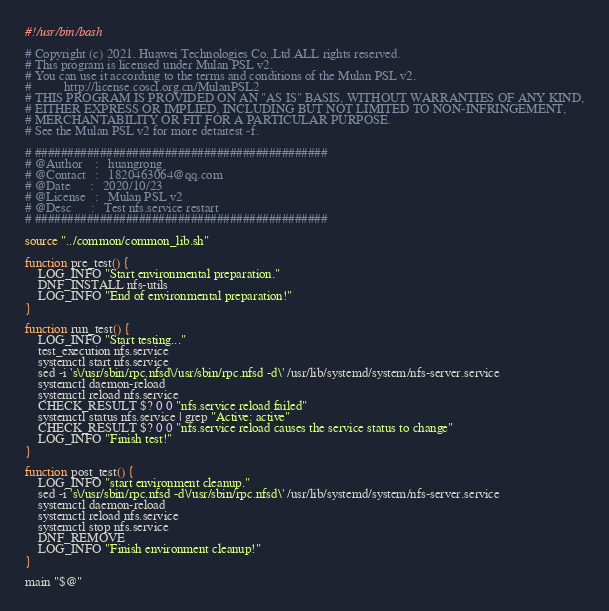Convert code to text. <code><loc_0><loc_0><loc_500><loc_500><_Bash_>#!/usr/bin/bash

# Copyright (c) 2021. Huawei Technologies Co.,Ltd.ALL rights reserved.
# This program is licensed under Mulan PSL v2.
# You can use it according to the terms and conditions of the Mulan PSL v2.
#          http://license.coscl.org.cn/MulanPSL2
# THIS PROGRAM IS PROVIDED ON AN "AS IS" BASIS, WITHOUT WARRANTIES OF ANY KIND,
# EITHER EXPRESS OR IMPLIED, INCLUDING BUT NOT LIMITED TO NON-INFRINGEMENT,
# MERCHANTABILITY OR FIT FOR A PARTICULAR PURPOSE.
# See the Mulan PSL v2 for more detaitest -f.

# #############################################
# @Author    :   huangrong
# @Contact   :   1820463064@qq.com
# @Date      :   2020/10/23
# @License   :   Mulan PSL v2
# @Desc      :   Test nfs.service restart
# #############################################

source "../common/common_lib.sh"

function pre_test() {
    LOG_INFO "Start environmental preparation."
    DNF_INSTALL nfs-utils
    LOG_INFO "End of environmental preparation!"
}

function run_test() {
    LOG_INFO "Start testing..."
    test_execution nfs.service
    systemctl start nfs.service
    sed -i 's\/usr/sbin/rpc.nfsd\/usr/sbin/rpc.nfsd -d\' /usr/lib/systemd/system/nfs-server.service
    systemctl daemon-reload
    systemctl reload nfs.service
    CHECK_RESULT $? 0 0 "nfs.service reload failed"
    systemctl status nfs.service | grep "Active: active"
    CHECK_RESULT $? 0 0 "nfs.service reload causes the service status to change"
    LOG_INFO "Finish test!"
}

function post_test() {
    LOG_INFO "start environment cleanup."
    sed -i 's\/usr/sbin/rpc.nfsd -d\/usr/sbin/rpc.nfsd\' /usr/lib/systemd/system/nfs-server.service
    systemctl daemon-reload
    systemctl reload nfs.service
    systemctl stop nfs.service
    DNF_REMOVE
    LOG_INFO "Finish environment cleanup!"
}

main "$@"
</code> 